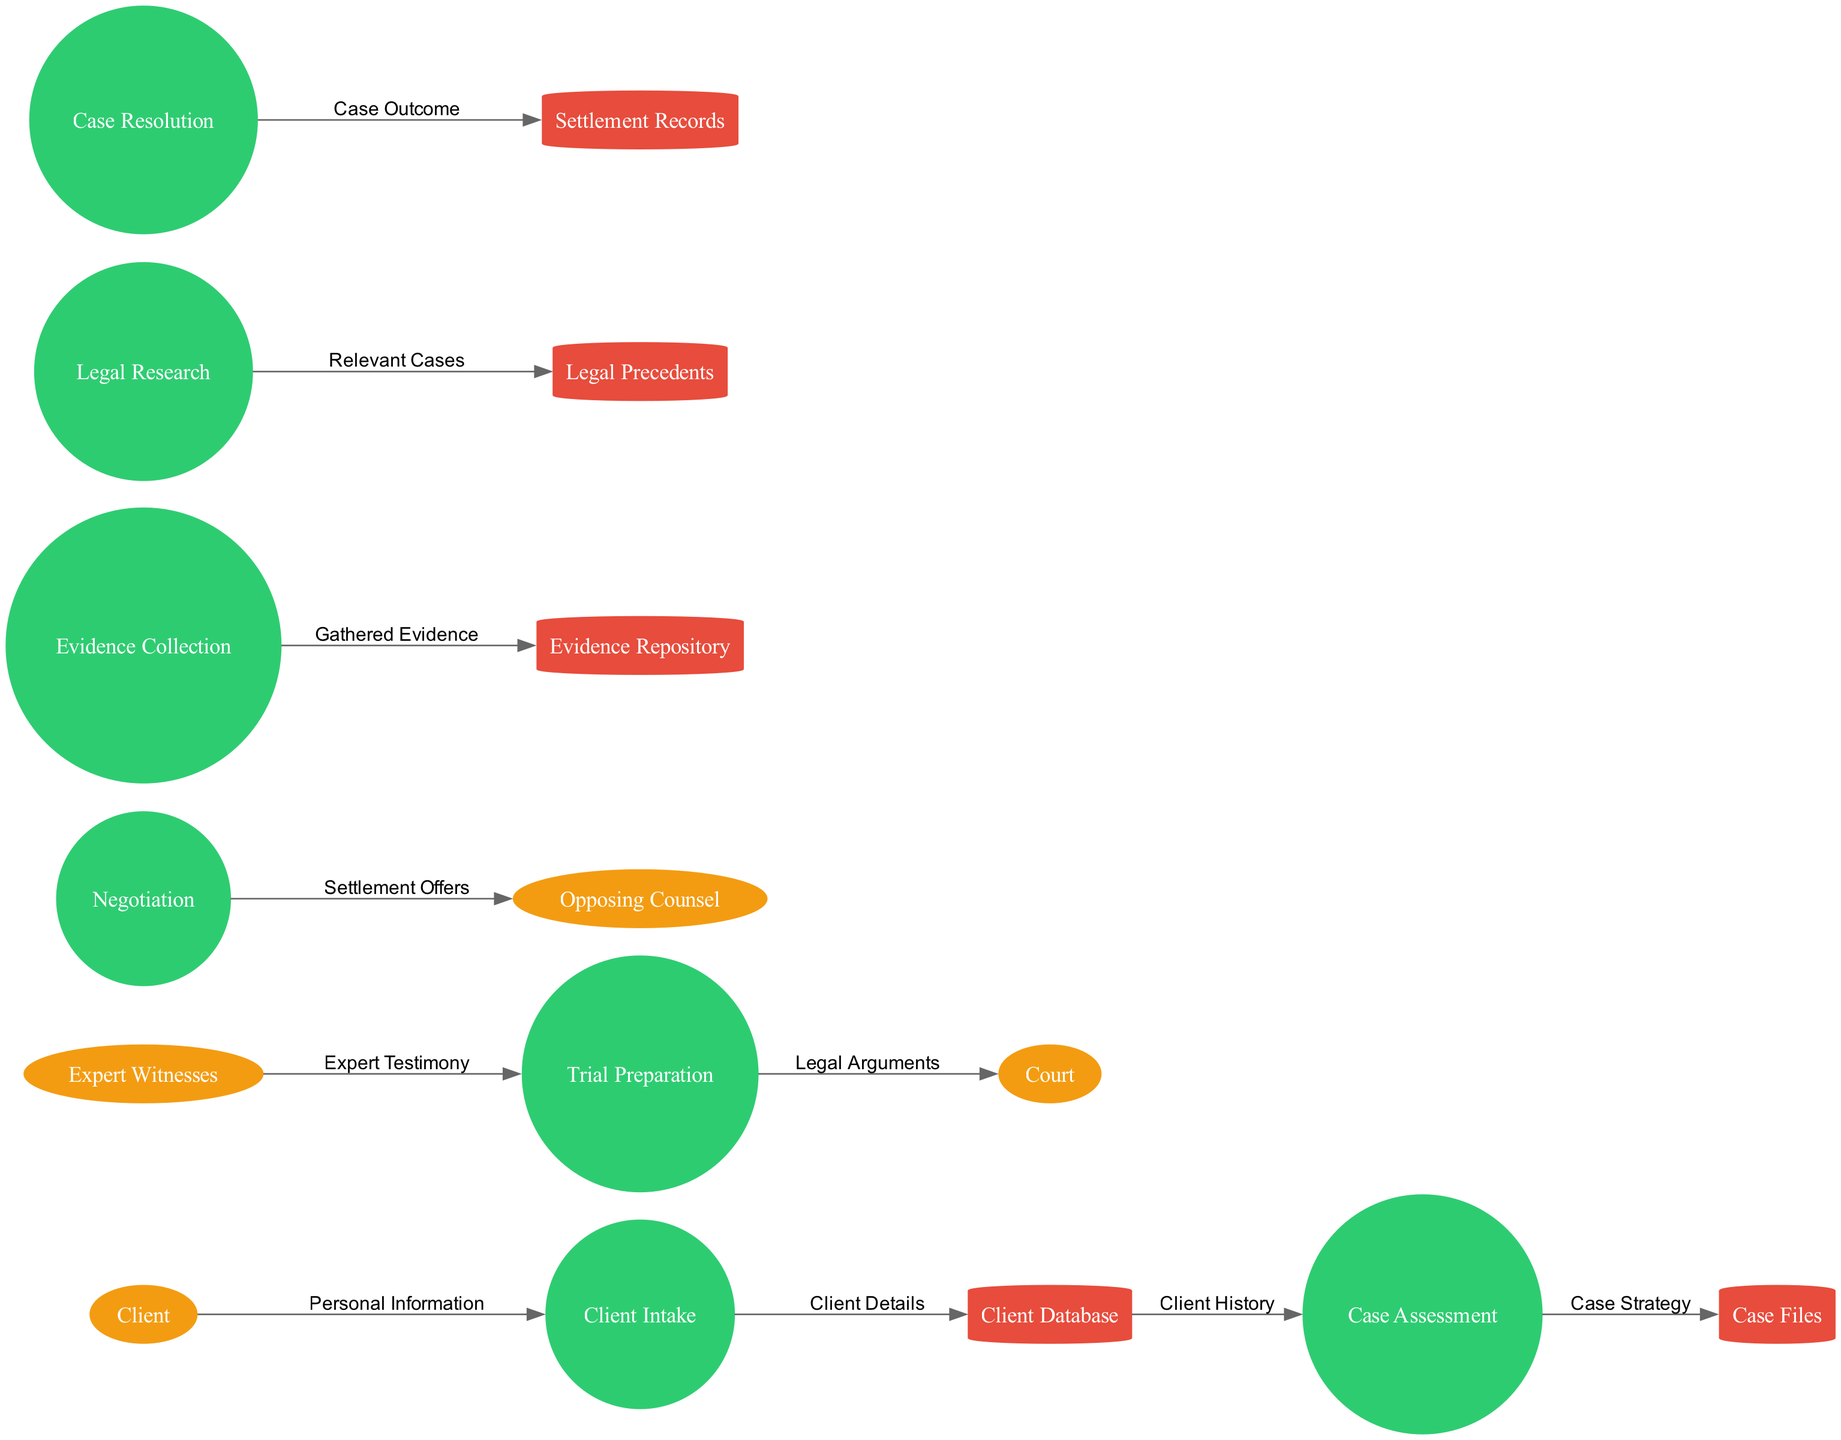What is the first process in the diagram? The diagram shows that the first process initiated in the legal case management system is the "Client Intake." This is located at the beginning of the flow from the external entity "Client."
Answer: Client Intake How many external entities are present? The diagram lists four external entities: "Client," "Court," "Opposing Counsel," and "Expert Witnesses," which can be counted directly from the external entities section.
Answer: Four Which process leads to the "Case Files" data store? Following the data flow, the "Case Assessment" process directs its output, labeled as "Case Strategy," to the "Case Files" data store. This is seen in the data flow relationship between these two nodes.
Answer: Case Assessment What is sent from "Expert Witnesses" to "Trial Preparation"? The data flow diagram indicates that "Expert Testimony" is the data sent from "Expert Witnesses" to the "Trial Preparation" process. This specific data flow relationship is clearly labeled in the diagram.
Answer: Expert Testimony What data flows from "Case Resolution" to "Settlement Records"? According to the diagram, the data labeled "Case Outcome" flows from the "Case Resolution" process to the "Settlement Records" data store. This connection is specified in the data flows section.
Answer: Case Outcome Which process has an outgoing flow to "Opposing Counsel"? The "Negotiation" process has an outgoing data flow to "Opposing Counsel." The associated label for this flow is "Settlement Offers," which indicates the relationship clearly in the diagram.
Answer: Negotiation What type of data store is "Evidence Repository"? The "Evidence Repository" is represented as a cylinder in the diagram, indicating that it is a data store type. This can be confirmed by examining its shape in the visual representation of the diagram.
Answer: Cylinder Which process precedes "Legal Research"? Analyzing the diagram, it can be determined that "Evidence Collection" is the process that occurs just before "Legal Research." This shows a sequential flow of processes in the legal case management system.
Answer: Evidence Collection 